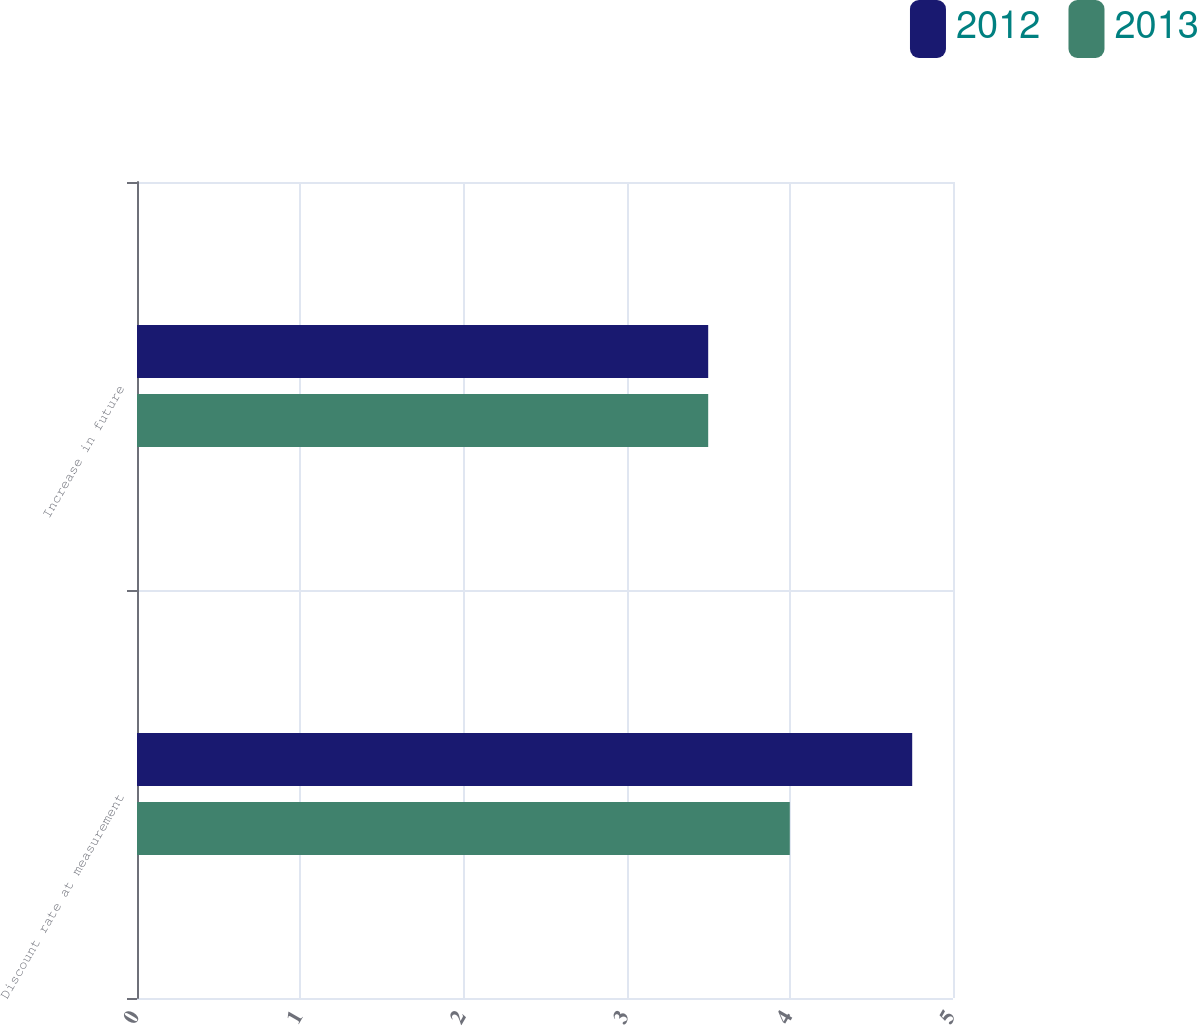Convert chart. <chart><loc_0><loc_0><loc_500><loc_500><stacked_bar_chart><ecel><fcel>Discount rate at measurement<fcel>Increase in future<nl><fcel>2012<fcel>4.75<fcel>3.5<nl><fcel>2013<fcel>4<fcel>3.5<nl></chart> 